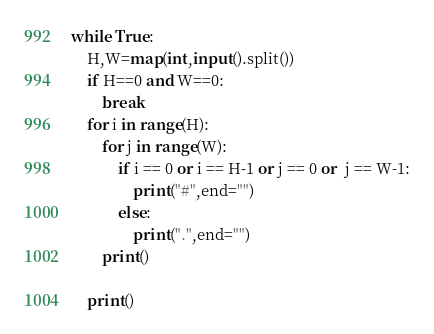<code> <loc_0><loc_0><loc_500><loc_500><_Python_>while True:
    H,W=map(int,input().split())
    if H==0 and W==0:
        break
    for i in range(H):
        for j in range(W):
            if i == 0 or i == H-1 or j == 0 or  j == W-1:
                print("#",end="")
            else:
                print(".",end="")
        print()
        
    print()
</code> 